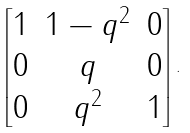Convert formula to latex. <formula><loc_0><loc_0><loc_500><loc_500>\begin{bmatrix} 1 & 1 - q ^ { 2 } & 0 \\ 0 & q & 0 \\ 0 & q ^ { 2 } & 1 \end{bmatrix} .</formula> 